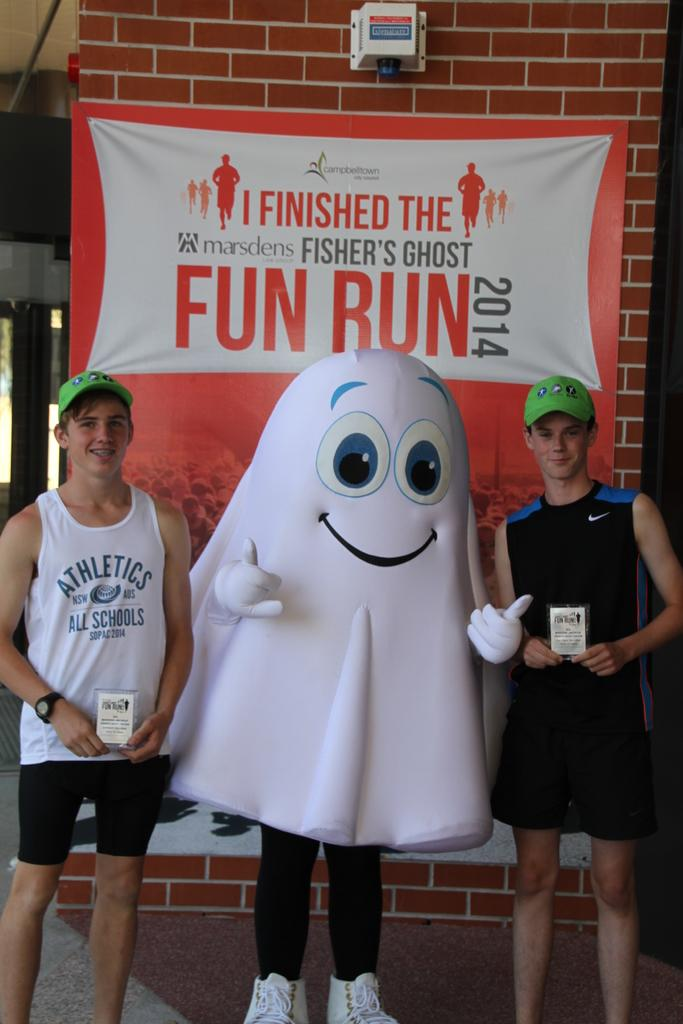How many people are in the image? There are three people in the image. What are the boys doing in the image? The boys are standing and smiling in the image. Who are the boys posing with? The boys are posing with a man. What is the man wearing in the image? The man is wearing a costume in the image. What type of cart can be seen in the image? There is no cart present in the image. What activity are the boys participating in while wearing low shoes? There is no mention of low shoes or any specific activity in the image. 